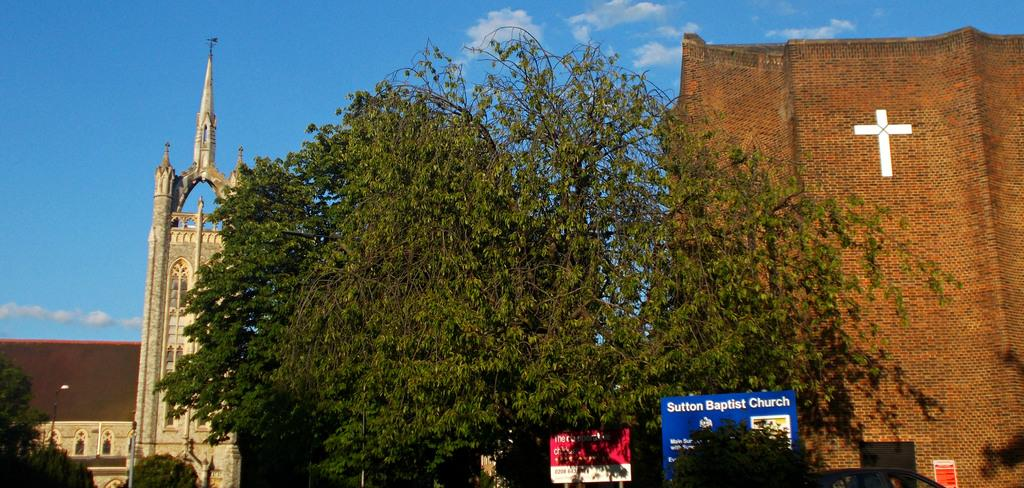What can be seen on the name boards in the image? The specific information on the name boards cannot be determined from the image. What type of vehicle is present in the image? The type of vehicle cannot be determined from the image. What type of vegetation is present in the image? Trees can be seen in the image. What type of structures are present in the image? Buildings are present in the image. What is visible in the background of the image? The sky with clouds is visible in the background of the image. Can you tell me how many grapes are hanging from the trees in the image? There are no grapes present in the image; only trees can be seen. What type of machine is being used by the people in the image? There are no people or machines present in the image. 